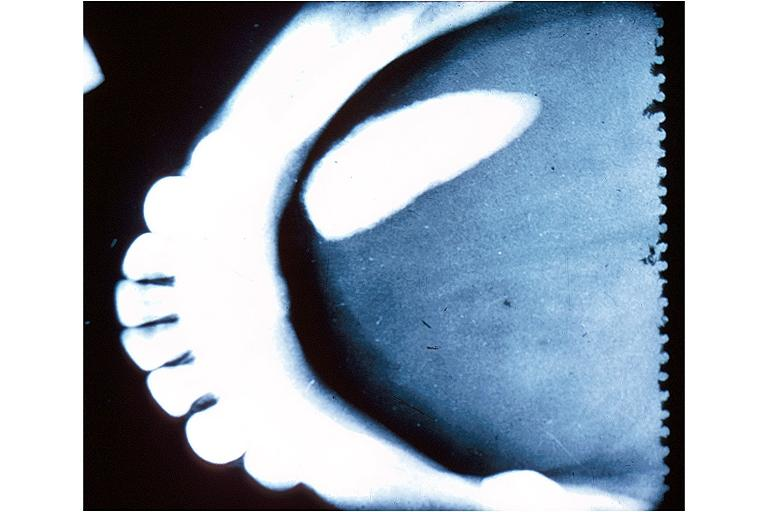s odontoid process subluxation with narrowing of foramen magnum present?
Answer the question using a single word or phrase. No 